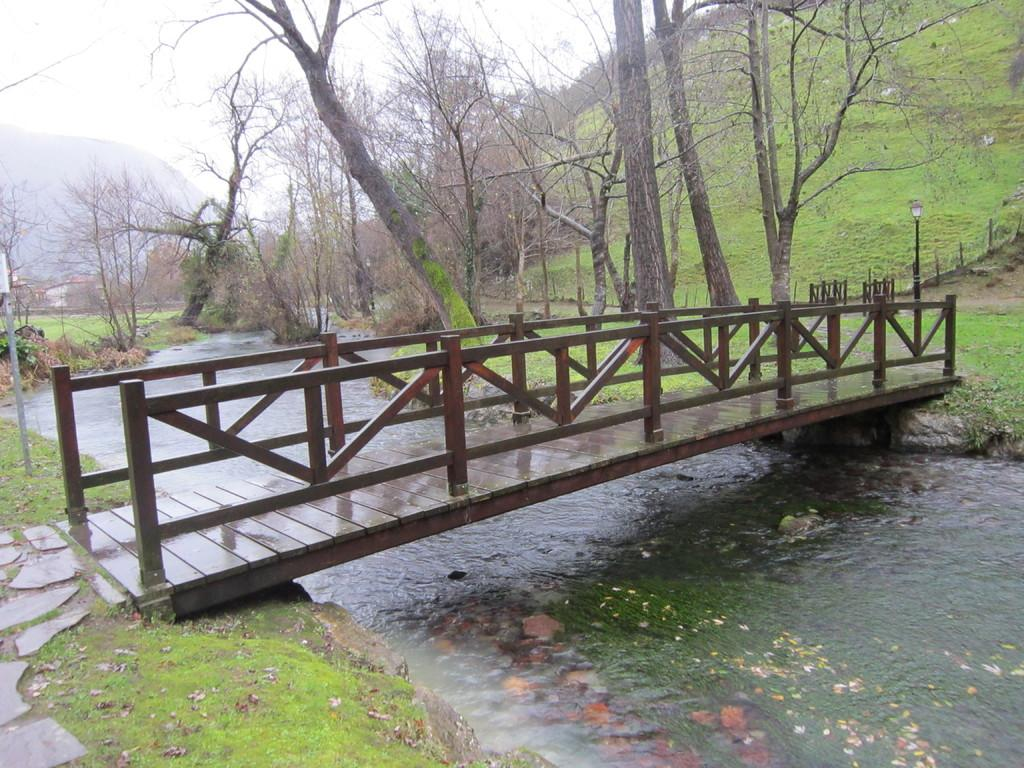What is the main structure in the center of the image? There is a bridge in the center of the image. What can be seen in the background of the image? There are trees, hills, and the sky visible in the background of the image. What is present at the bottom of the image? There is water and grass visible at the bottom of the image. Can you describe the pole on the right side of the image? There is a pole on the right side of the image. What type of cork can be seen floating in the water in the image? There is no cork present in the image; it only features a bridge, trees, hills, sky, water, grass, and a pole. 